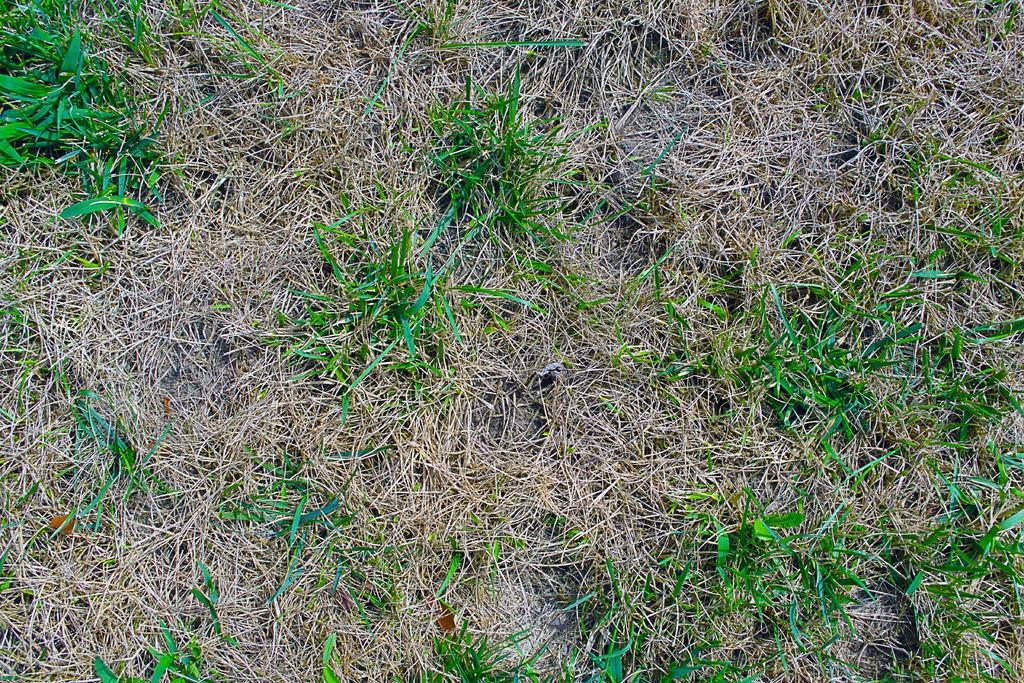What type of landscape is depicted in the image? There is a grassland in the image. What kind of toys can be seen scattered across the grassland in the image? There are no toys present in the image; it only depicts a grassland. How many cows are causing trouble in the grassland in the image? There are no cows or any indication of trouble in the image; it only depicts a grassland. 